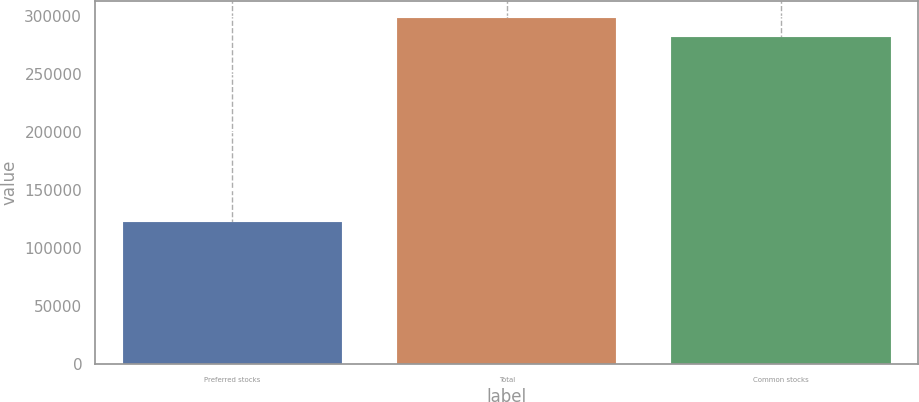Convert chart. <chart><loc_0><loc_0><loc_500><loc_500><bar_chart><fcel>Preferred stocks<fcel>Total<fcel>Common stocks<nl><fcel>122563<fcel>298144<fcel>282066<nl></chart> 